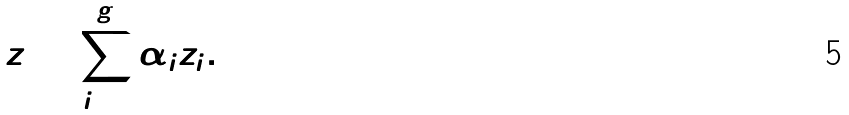<formula> <loc_0><loc_0><loc_500><loc_500>z = \sum _ { i = 1 } ^ { g } \alpha _ { i } z _ { i } .</formula> 